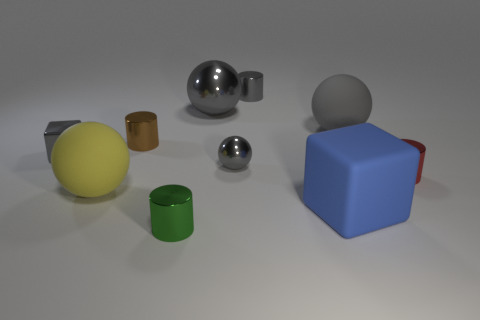Are there more small metallic blocks that are to the right of the yellow thing than metal things that are right of the big blue rubber cube?
Offer a terse response. No. There is a gray thing that is both in front of the gray rubber ball and to the right of the brown object; what material is it?
Your answer should be compact. Metal. What color is the big shiny object that is the same shape as the big yellow rubber object?
Your answer should be compact. Gray. The brown metallic cylinder has what size?
Ensure brevity in your answer.  Small. The matte sphere that is left of the rubber ball on the right side of the yellow matte thing is what color?
Provide a succinct answer. Yellow. What number of metallic cylinders are left of the blue matte block and behind the large blue block?
Provide a succinct answer. 2. Is the number of gray matte objects greater than the number of tiny purple metal blocks?
Provide a short and direct response. Yes. What is the material of the large yellow object?
Ensure brevity in your answer.  Rubber. There is a rubber sphere in front of the tiny brown cylinder; what number of large spheres are behind it?
Keep it short and to the point. 2. There is a large cube; does it have the same color as the small metallic cylinder that is on the right side of the gray metal cylinder?
Your response must be concise. No. 